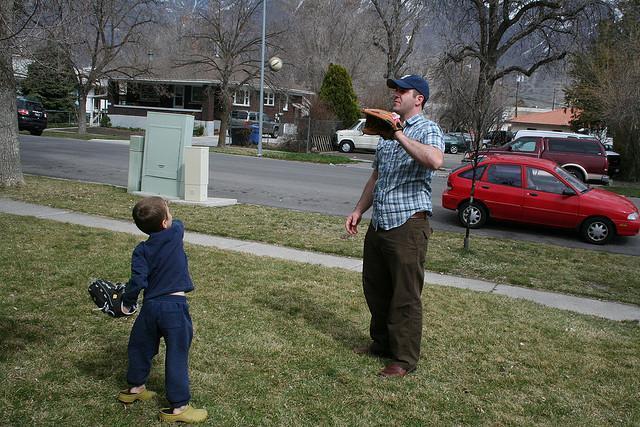How many vehicles can be seen?
Give a very brief answer. 7. How many people are there?
Give a very brief answer. 2. How many sheep are seen?
Give a very brief answer. 0. 